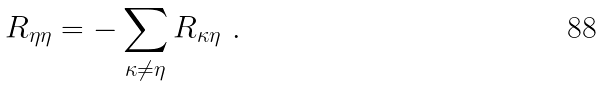Convert formula to latex. <formula><loc_0><loc_0><loc_500><loc_500>R _ { \eta \eta } = - \sum _ { \kappa \neq \eta } R _ { \kappa \eta } \ .</formula> 